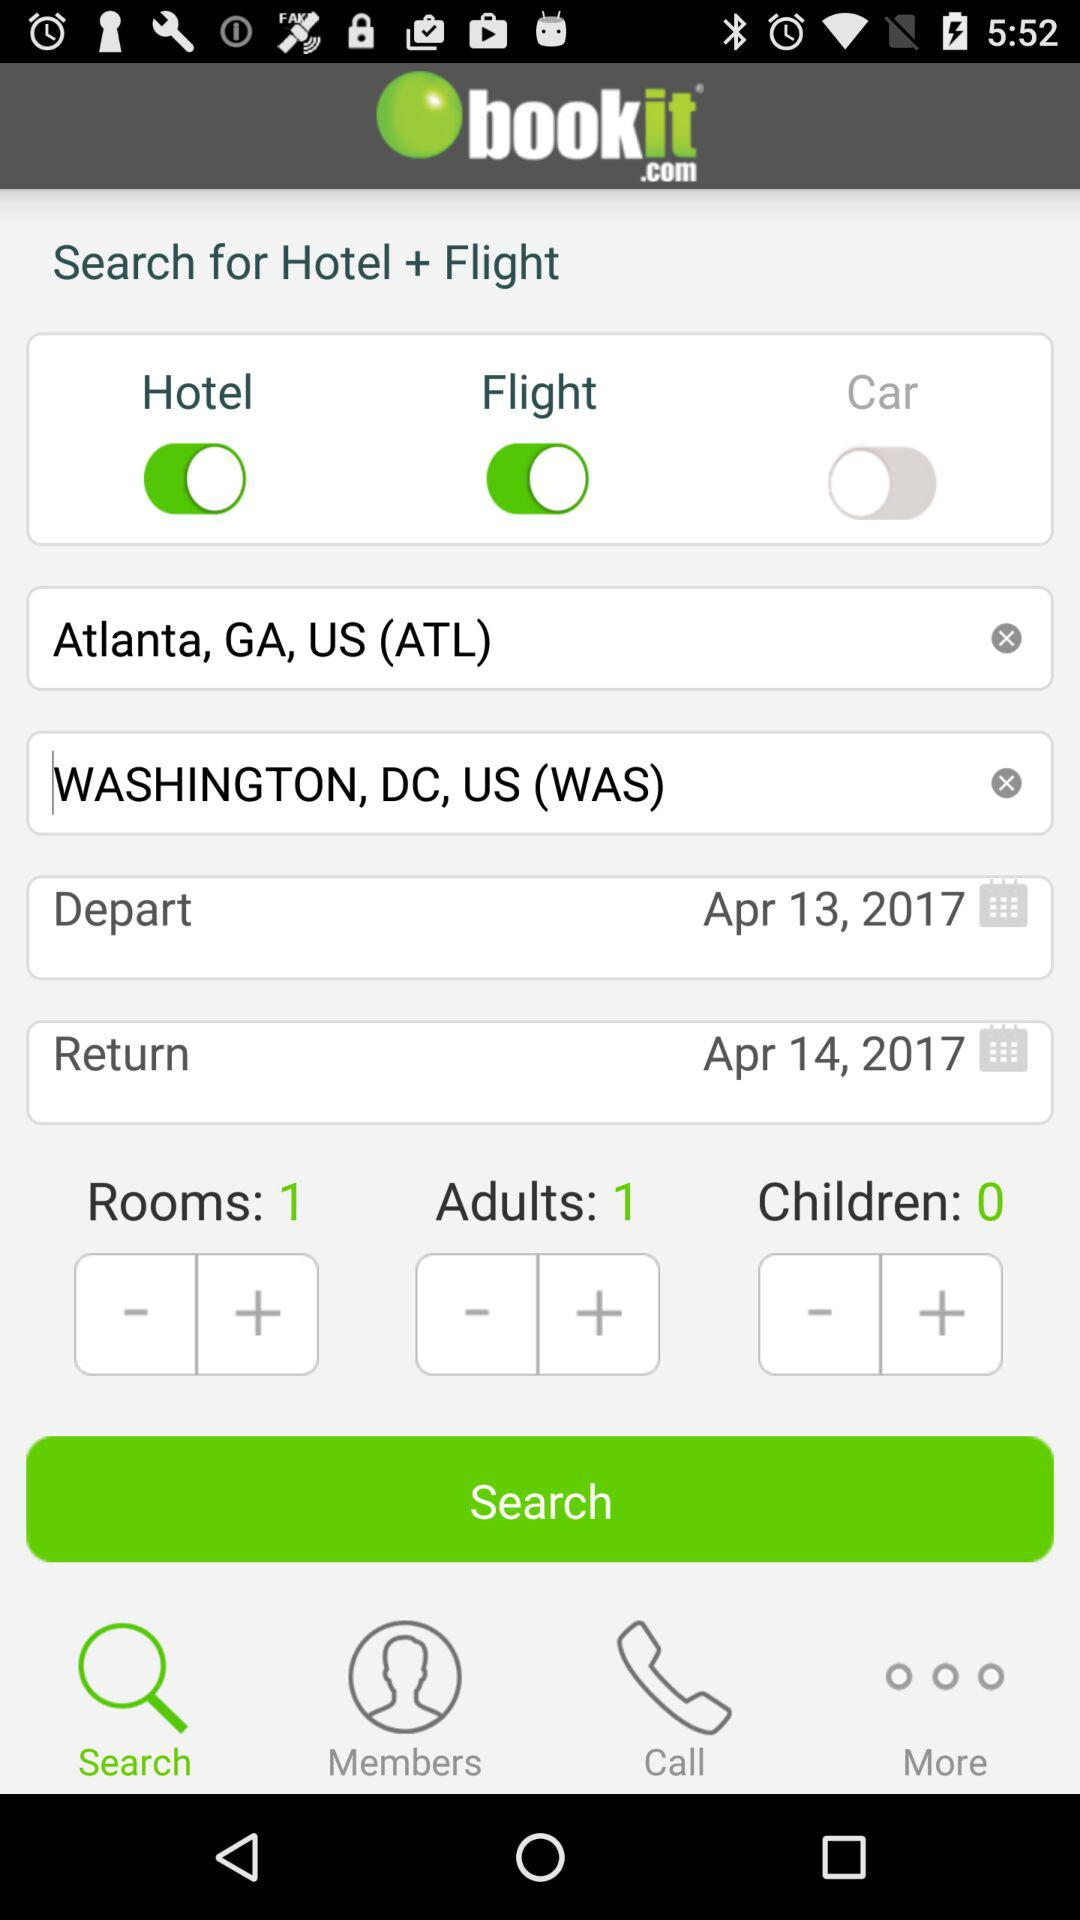How many more adults than children are there?
Answer the question using a single word or phrase. 1 